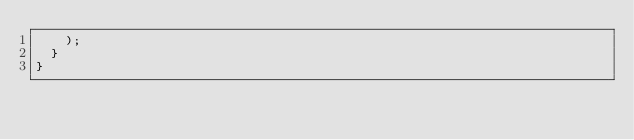<code> <loc_0><loc_0><loc_500><loc_500><_JavaScript_>    );
  }
}
</code> 